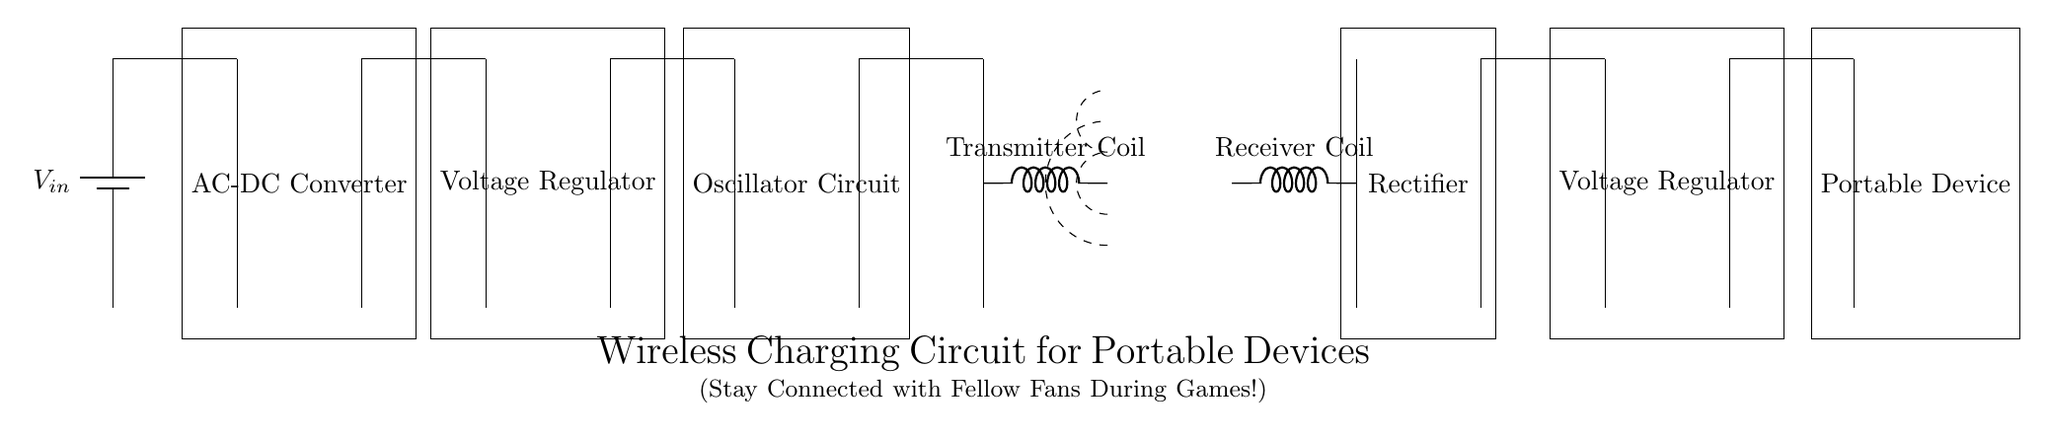What is the input power source for this circuit? The circuit diagram shows a battery labeled as V_in, which serves as the input power source. This indicates that the circuit relies on a battery for initial energy.
Answer: V_in What are the two types of coils present in this circuit? The circuit contains a transmitter coil and a receiver coil, both indicated as inductors in the diagram. The transmitter coil is used to create the magnetic field, while the receiver coil captures it.
Answer: Transmitter Coil and Receiver Coil How many voltage regulators are in the circuit? There are two voltage regulators visible in the circuit diagram. The first voltage regulator is positioned after the AC-DC converter, and the second is positioned after the rectifier.
Answer: 2 What role does the AC-DC converter play in this circuit? The AC-DC converter transforms alternating current to direct current. This is essential since portable devices typically operate on direct current. The converter's function is critical at the start of the power supply.
Answer: Converts AC to DC What is the purpose of the oscillator circuit in this wireless charging system? The oscillator circuit generates alternating current, which is needed to create the oscillating magnetic field that wirelessly transfers power from the transmitter coil to the receiver coil. Its role is fundamental for efficient energy transfer.
Answer: Generates alternating current Where does the output voltage go after the second voltage regulator? The output voltage is directed to the portable device, which is the load that requires power for operation. The portable device is the final component in the circuit, completing the power delivery process.
Answer: Portable Device 